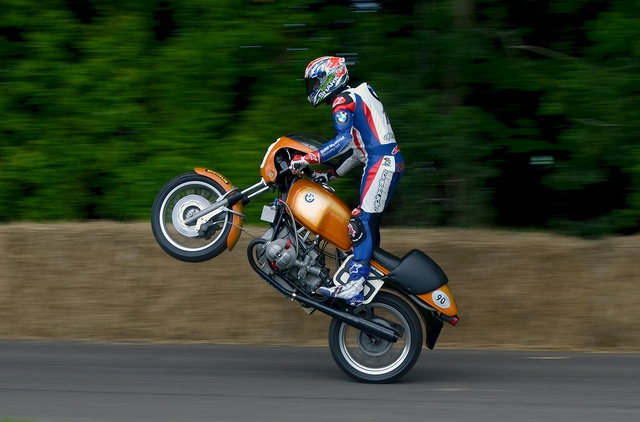Describe the objects in this image and their specific colors. I can see motorcycle in darkgreen, black, gray, blue, and lightgray tones and people in darkgreen, lightgray, black, navy, and blue tones in this image. 